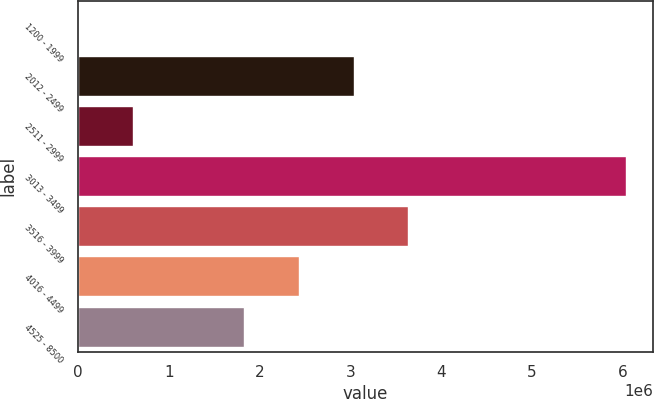Convert chart. <chart><loc_0><loc_0><loc_500><loc_500><bar_chart><fcel>1200 - 1999<fcel>2012 - 2499<fcel>2511 - 2999<fcel>3013 - 3499<fcel>3516 - 3999<fcel>4016 - 4499<fcel>4525 - 8500<nl><fcel>5969<fcel>3.03325e+06<fcel>608287<fcel>6.02915e+06<fcel>3.63557e+06<fcel>2.43093e+06<fcel>1.82861e+06<nl></chart> 